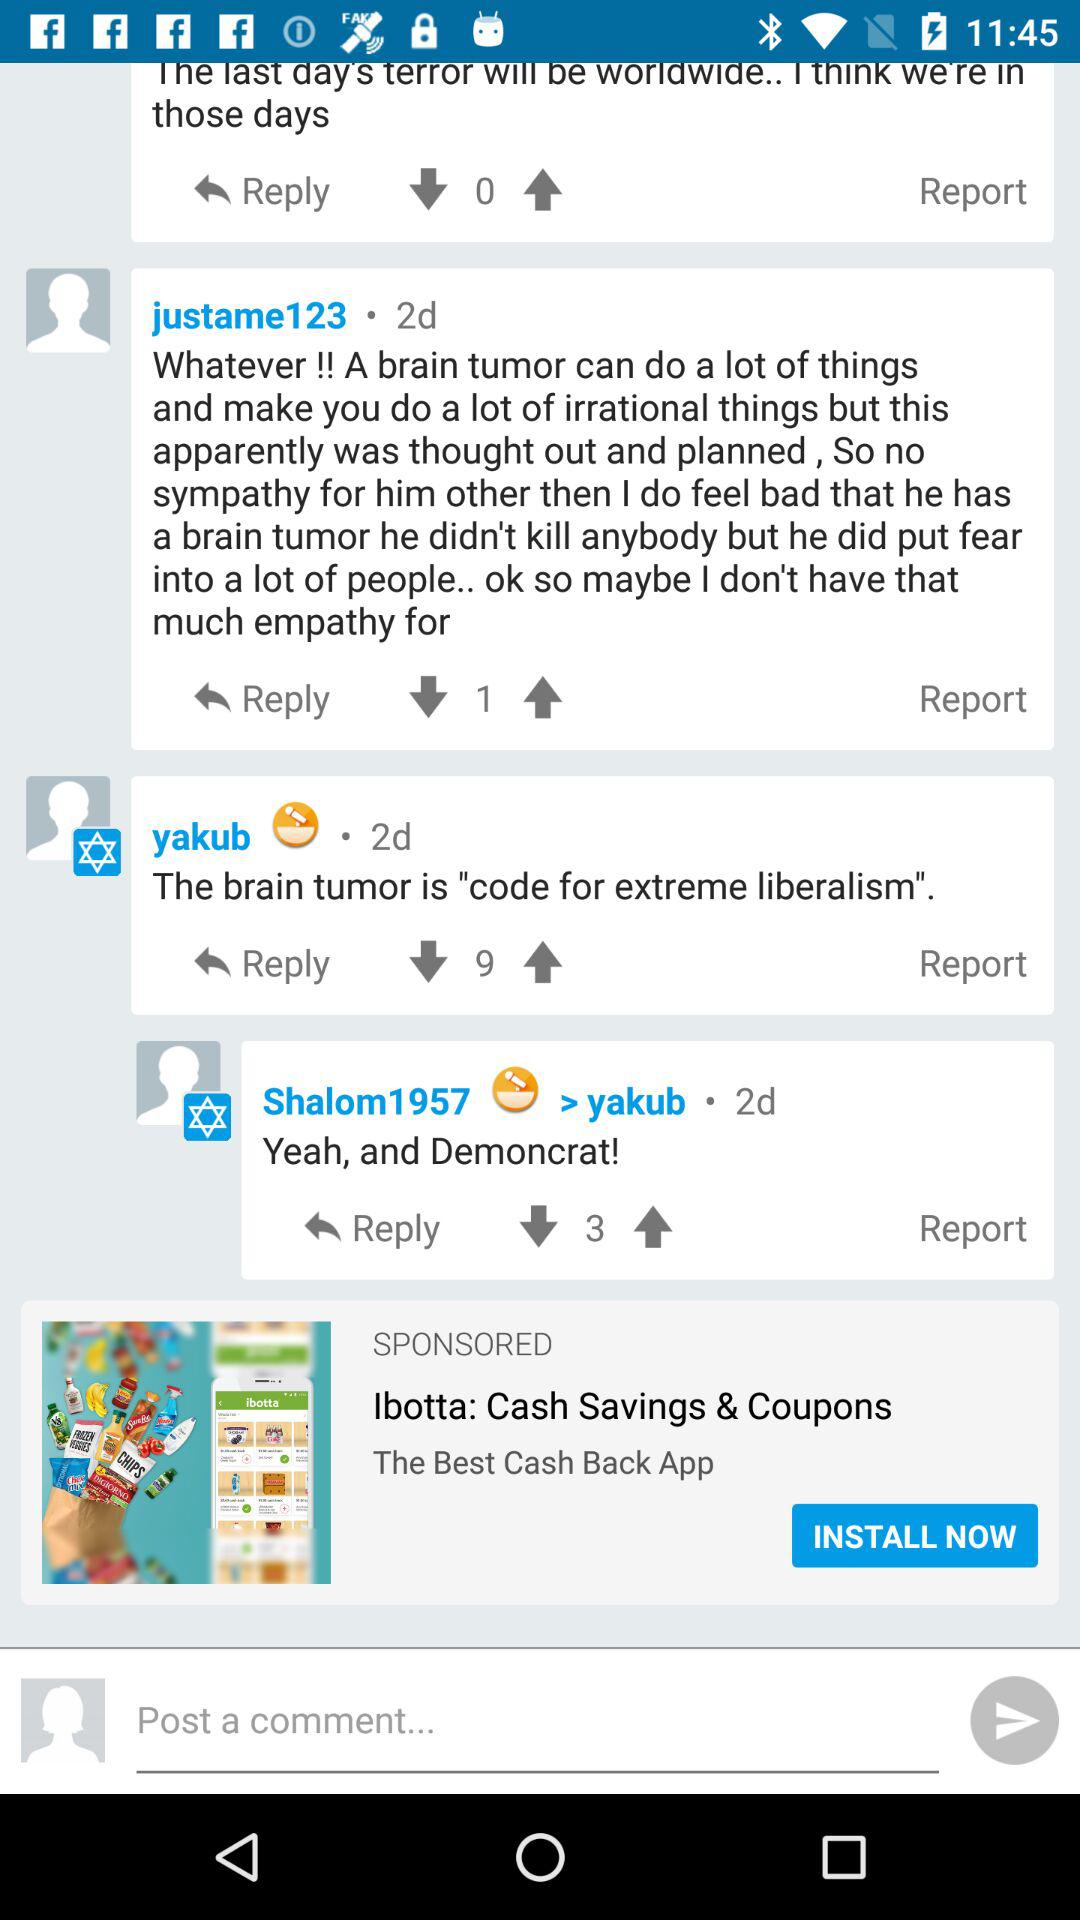What application is asking for permission? The application asking for permission is "Riversip". 